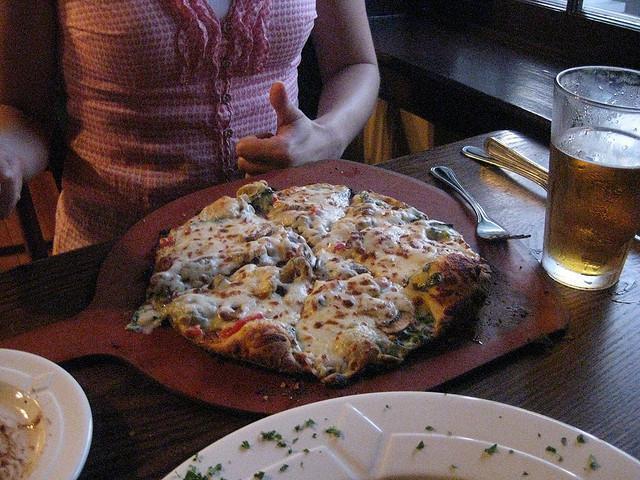Verify the accuracy of this image caption: "The pizza is at the edge of the dining table.".
Answer yes or no. Yes. 